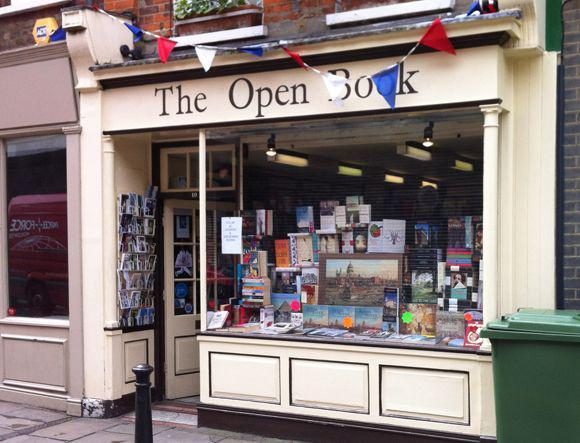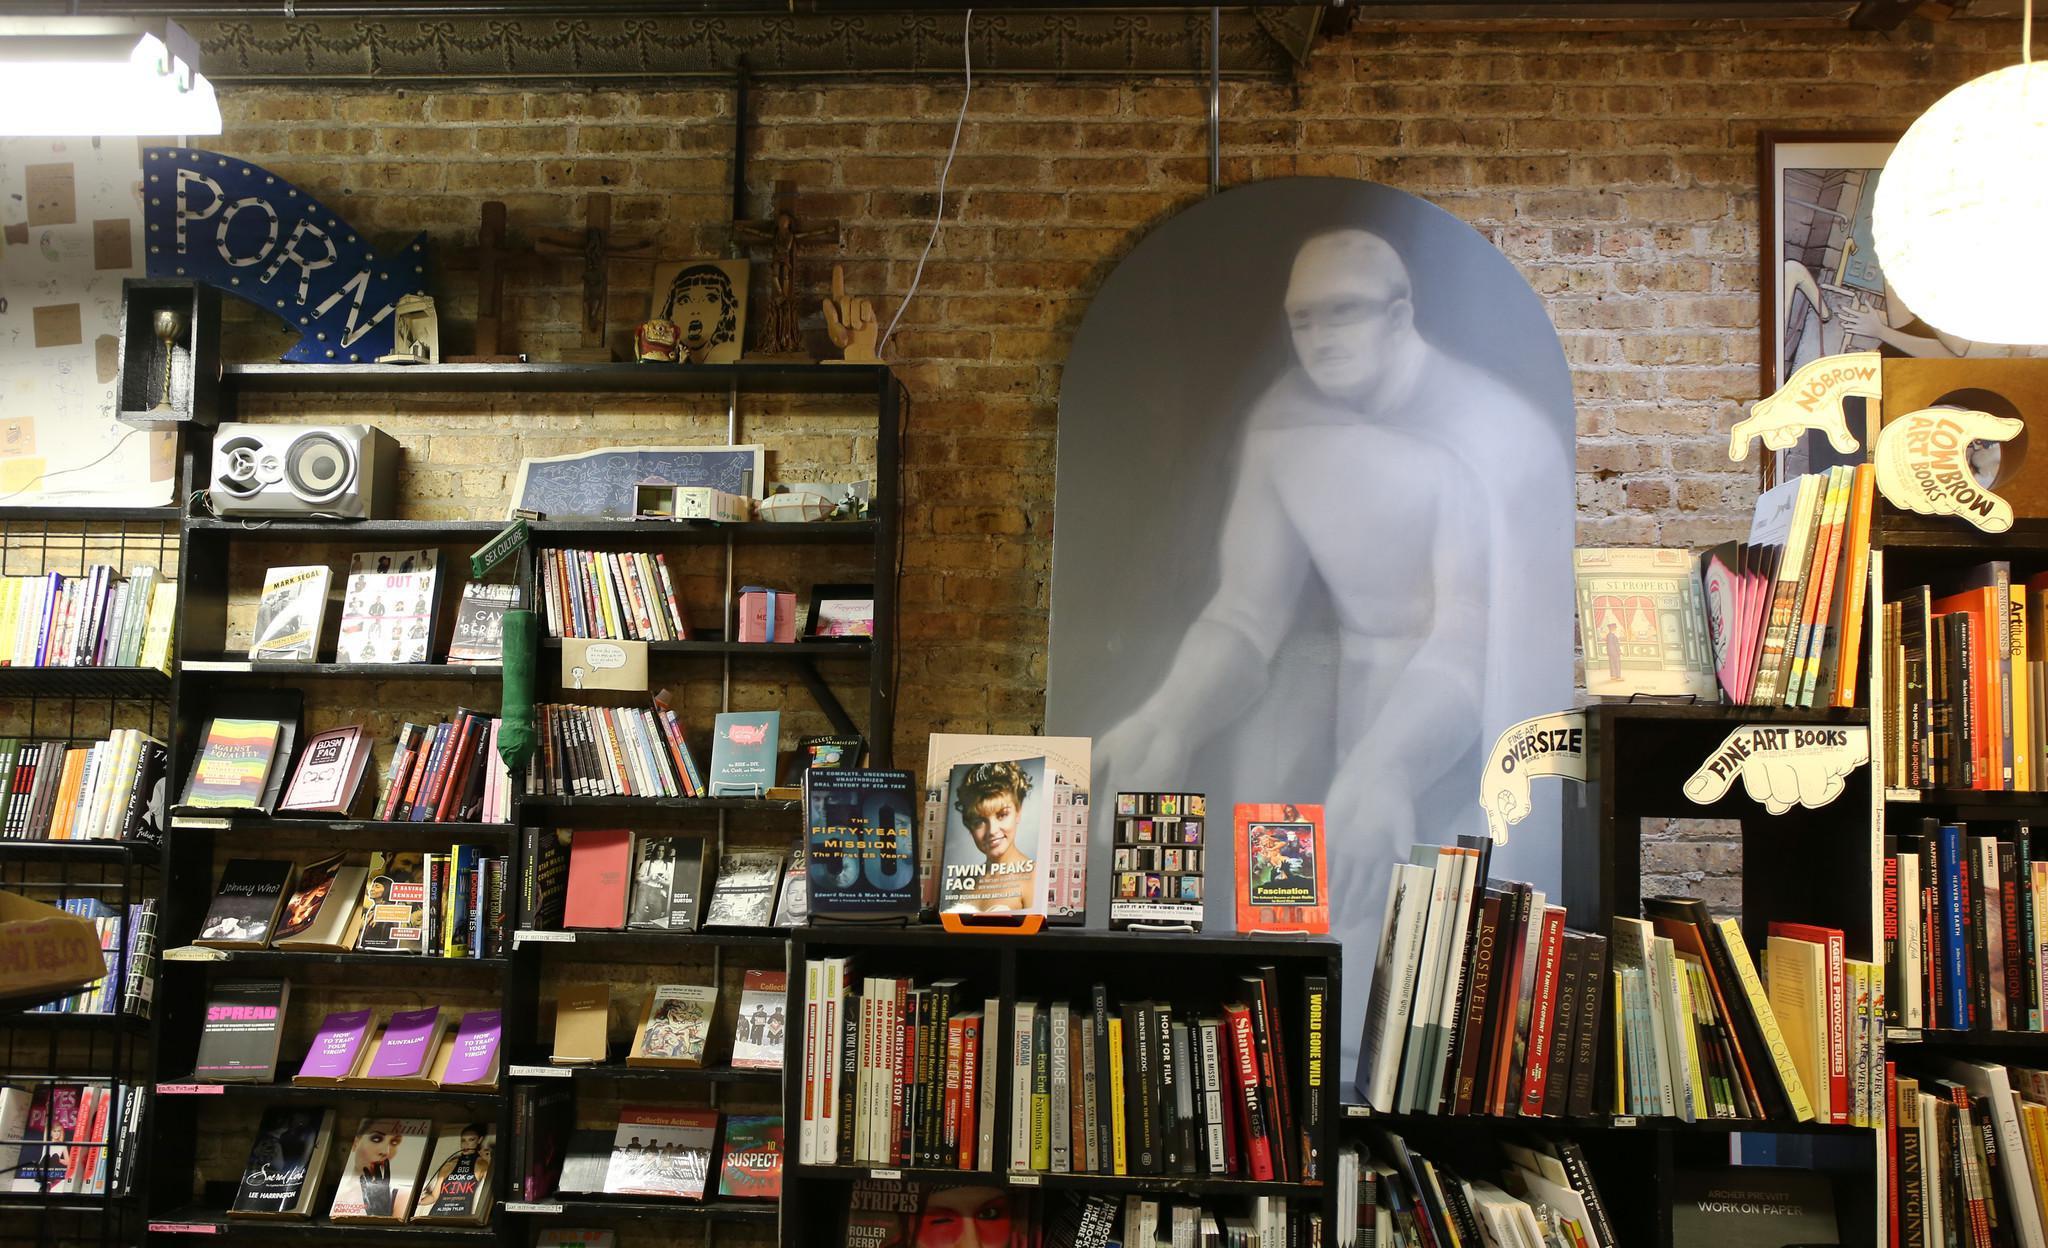The first image is the image on the left, the second image is the image on the right. For the images displayed, is the sentence "There are at least two cardboard boxes of books on the pavement outside the book shop." factually correct? Answer yes or no. No. The first image is the image on the left, the second image is the image on the right. Assess this claim about the two images: "One storefront has light stone bordering around wood that is painted navy blue.". Correct or not? Answer yes or no. No. 